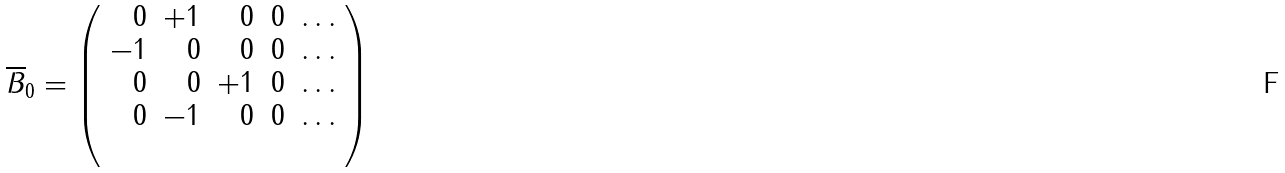<formula> <loc_0><loc_0><loc_500><loc_500>\overline { B } _ { 0 } = \left ( \begin{array} { r r r r r } 0 & + 1 & 0 & 0 & \dots \\ - 1 & 0 & 0 & 0 & \dots \\ 0 & 0 & + 1 & 0 & \dots \\ 0 & - 1 & 0 & 0 & \dots \\ \\ \end{array} \right )</formula> 